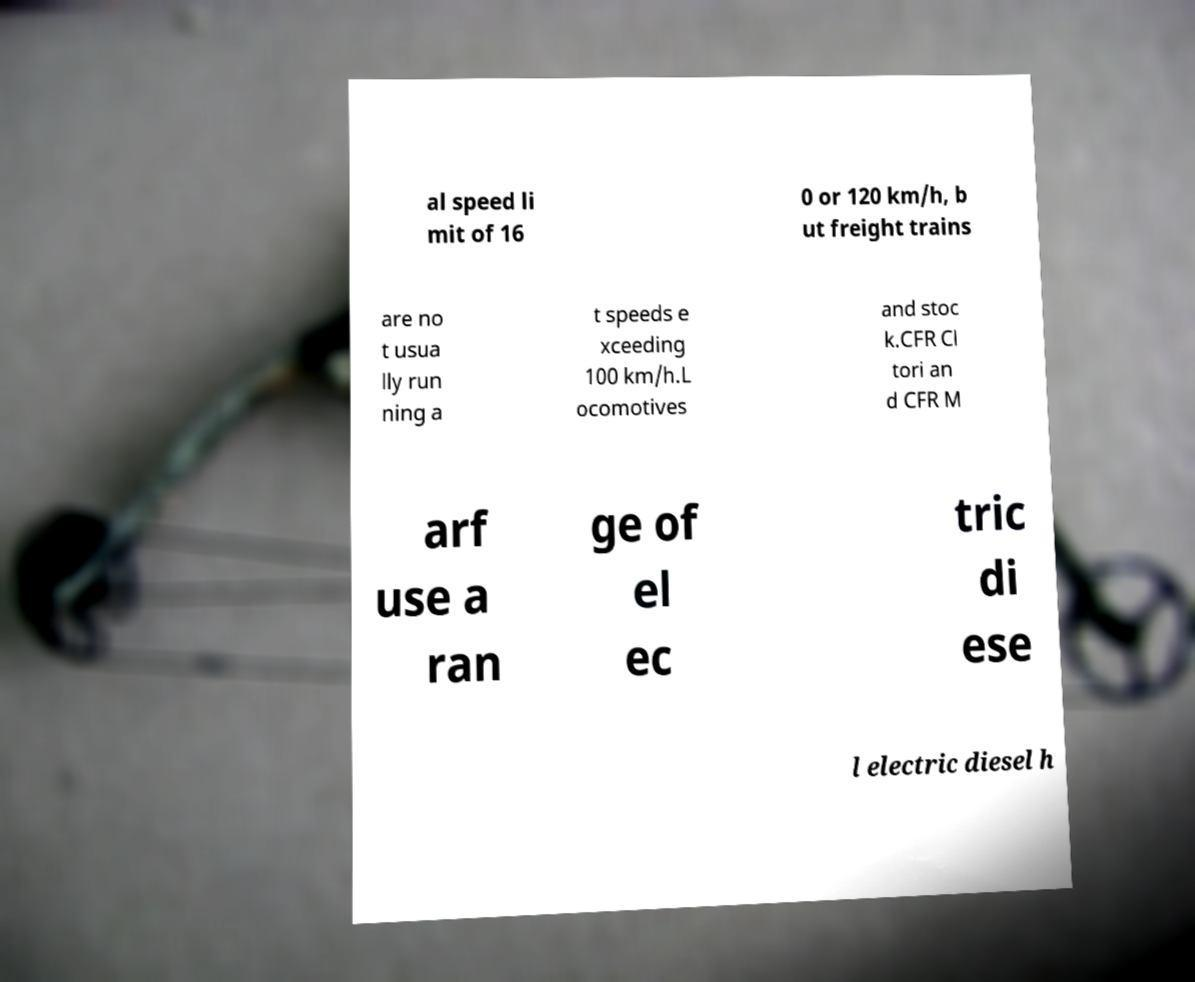Can you read and provide the text displayed in the image?This photo seems to have some interesting text. Can you extract and type it out for me? al speed li mit of 16 0 or 120 km/h, b ut freight trains are no t usua lly run ning a t speeds e xceeding 100 km/h.L ocomotives and stoc k.CFR Cl tori an d CFR M arf use a ran ge of el ec tric di ese l electric diesel h 